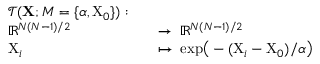<formula> <loc_0><loc_0><loc_500><loc_500>\begin{array} { r l r l } & { \mathcal { T } ( X ; M = \{ \alpha , X _ { 0 } \} ) \colon } \\ & { \mathbb { R } ^ { N ( N - 1 ) / 2 } } & & { \to \, \mathbb { R } ^ { N ( N - 1 ) / 2 } } \\ & { X _ { i } } & & { \mapsto \, e x p \left ( - ( X _ { i } - X _ { 0 } ) / \alpha \right ) } \end{array}</formula> 